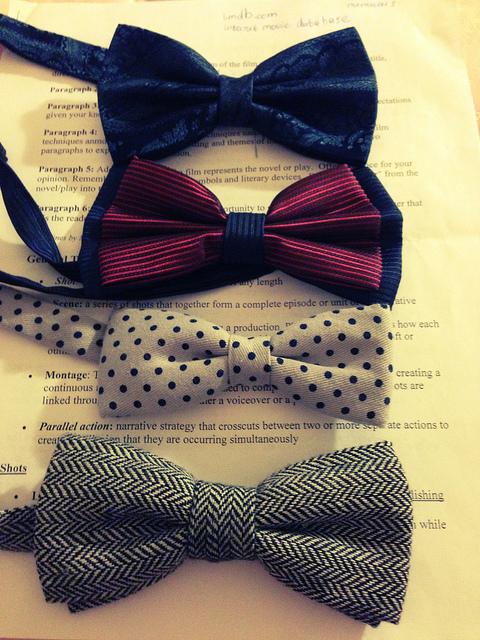Where is the polka dotted tie?
Give a very brief answer. Second from bottom. How many bow ties are on the paper?
Concise answer only. 4. How many blue ties do you see?
Write a very short answer. 1. 